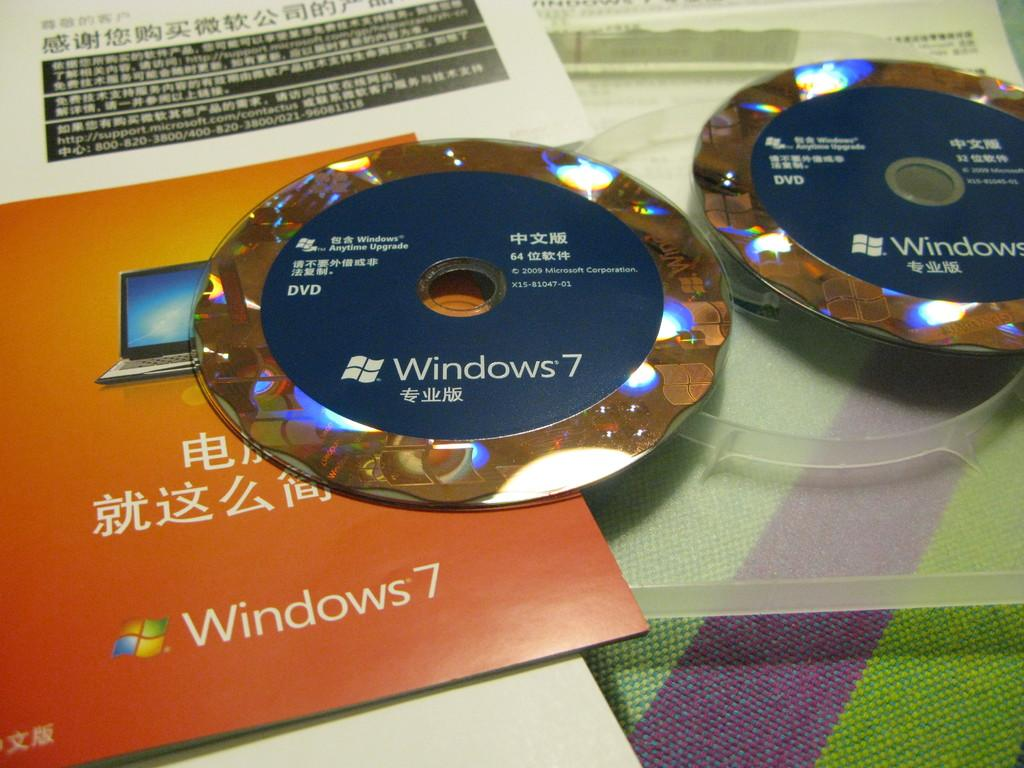<image>
Relay a brief, clear account of the picture shown. Windows 7 CD on top of an orange Windows 7 manual. 